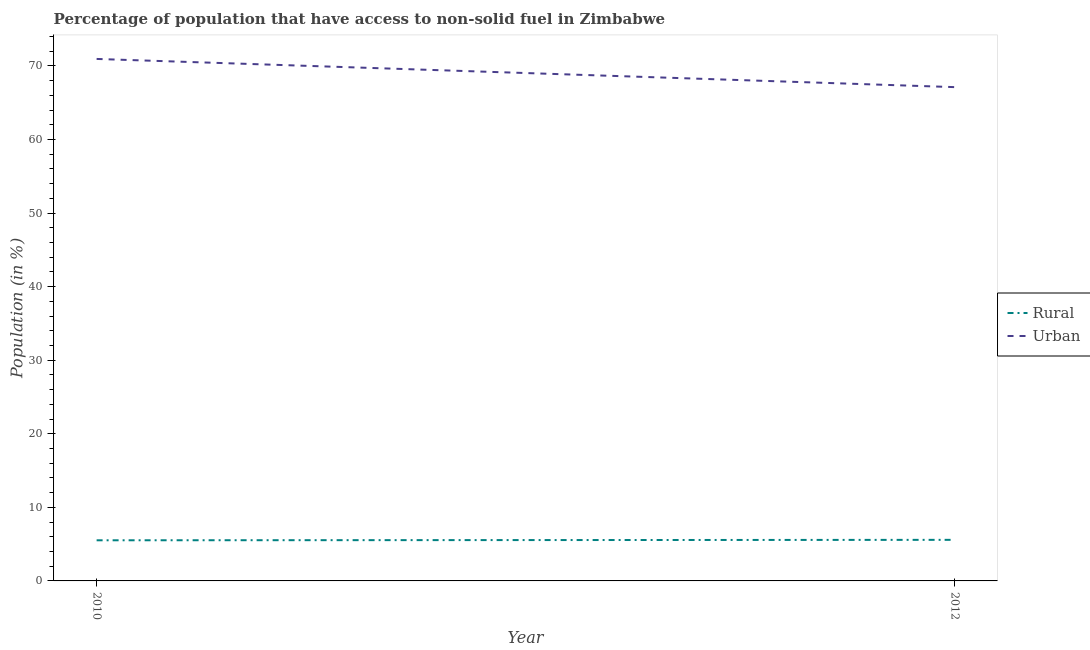How many different coloured lines are there?
Your response must be concise. 2. Does the line corresponding to urban population intersect with the line corresponding to rural population?
Your response must be concise. No. What is the rural population in 2012?
Provide a short and direct response. 5.58. Across all years, what is the maximum urban population?
Offer a terse response. 70.94. Across all years, what is the minimum rural population?
Provide a short and direct response. 5.52. What is the total urban population in the graph?
Give a very brief answer. 138.06. What is the difference between the urban population in 2010 and that in 2012?
Offer a very short reply. 3.83. What is the difference between the urban population in 2012 and the rural population in 2010?
Give a very brief answer. 61.59. What is the average urban population per year?
Ensure brevity in your answer.  69.03. In the year 2012, what is the difference between the rural population and urban population?
Ensure brevity in your answer.  -61.53. In how many years, is the urban population greater than 70 %?
Provide a short and direct response. 1. What is the ratio of the rural population in 2010 to that in 2012?
Your answer should be very brief. 0.99. Is the urban population in 2010 less than that in 2012?
Give a very brief answer. No. Does the urban population monotonically increase over the years?
Provide a short and direct response. No. Is the rural population strictly greater than the urban population over the years?
Give a very brief answer. No. Is the rural population strictly less than the urban population over the years?
Offer a very short reply. Yes. How many lines are there?
Offer a terse response. 2. What is the difference between two consecutive major ticks on the Y-axis?
Offer a terse response. 10. How many legend labels are there?
Keep it short and to the point. 2. How are the legend labels stacked?
Keep it short and to the point. Vertical. What is the title of the graph?
Give a very brief answer. Percentage of population that have access to non-solid fuel in Zimbabwe. Does "Private consumption" appear as one of the legend labels in the graph?
Offer a terse response. No. What is the label or title of the Y-axis?
Provide a succinct answer. Population (in %). What is the Population (in %) of Rural in 2010?
Your answer should be very brief. 5.52. What is the Population (in %) of Urban in 2010?
Your answer should be very brief. 70.94. What is the Population (in %) of Rural in 2012?
Offer a terse response. 5.58. What is the Population (in %) in Urban in 2012?
Keep it short and to the point. 67.11. Across all years, what is the maximum Population (in %) of Rural?
Your answer should be very brief. 5.58. Across all years, what is the maximum Population (in %) in Urban?
Provide a succinct answer. 70.94. Across all years, what is the minimum Population (in %) of Rural?
Offer a terse response. 5.52. Across all years, what is the minimum Population (in %) of Urban?
Your answer should be compact. 67.11. What is the total Population (in %) in Rural in the graph?
Provide a short and direct response. 11.11. What is the total Population (in %) in Urban in the graph?
Make the answer very short. 138.06. What is the difference between the Population (in %) of Rural in 2010 and that in 2012?
Offer a very short reply. -0.06. What is the difference between the Population (in %) in Urban in 2010 and that in 2012?
Ensure brevity in your answer.  3.83. What is the difference between the Population (in %) in Rural in 2010 and the Population (in %) in Urban in 2012?
Keep it short and to the point. -61.59. What is the average Population (in %) in Rural per year?
Your answer should be very brief. 5.55. What is the average Population (in %) in Urban per year?
Give a very brief answer. 69.03. In the year 2010, what is the difference between the Population (in %) in Rural and Population (in %) in Urban?
Your response must be concise. -65.42. In the year 2012, what is the difference between the Population (in %) in Rural and Population (in %) in Urban?
Your answer should be compact. -61.53. What is the ratio of the Population (in %) in Rural in 2010 to that in 2012?
Make the answer very short. 0.99. What is the ratio of the Population (in %) of Urban in 2010 to that in 2012?
Your answer should be compact. 1.06. What is the difference between the highest and the second highest Population (in %) of Rural?
Your response must be concise. 0.06. What is the difference between the highest and the second highest Population (in %) in Urban?
Your answer should be very brief. 3.83. What is the difference between the highest and the lowest Population (in %) in Rural?
Your answer should be compact. 0.06. What is the difference between the highest and the lowest Population (in %) of Urban?
Provide a short and direct response. 3.83. 